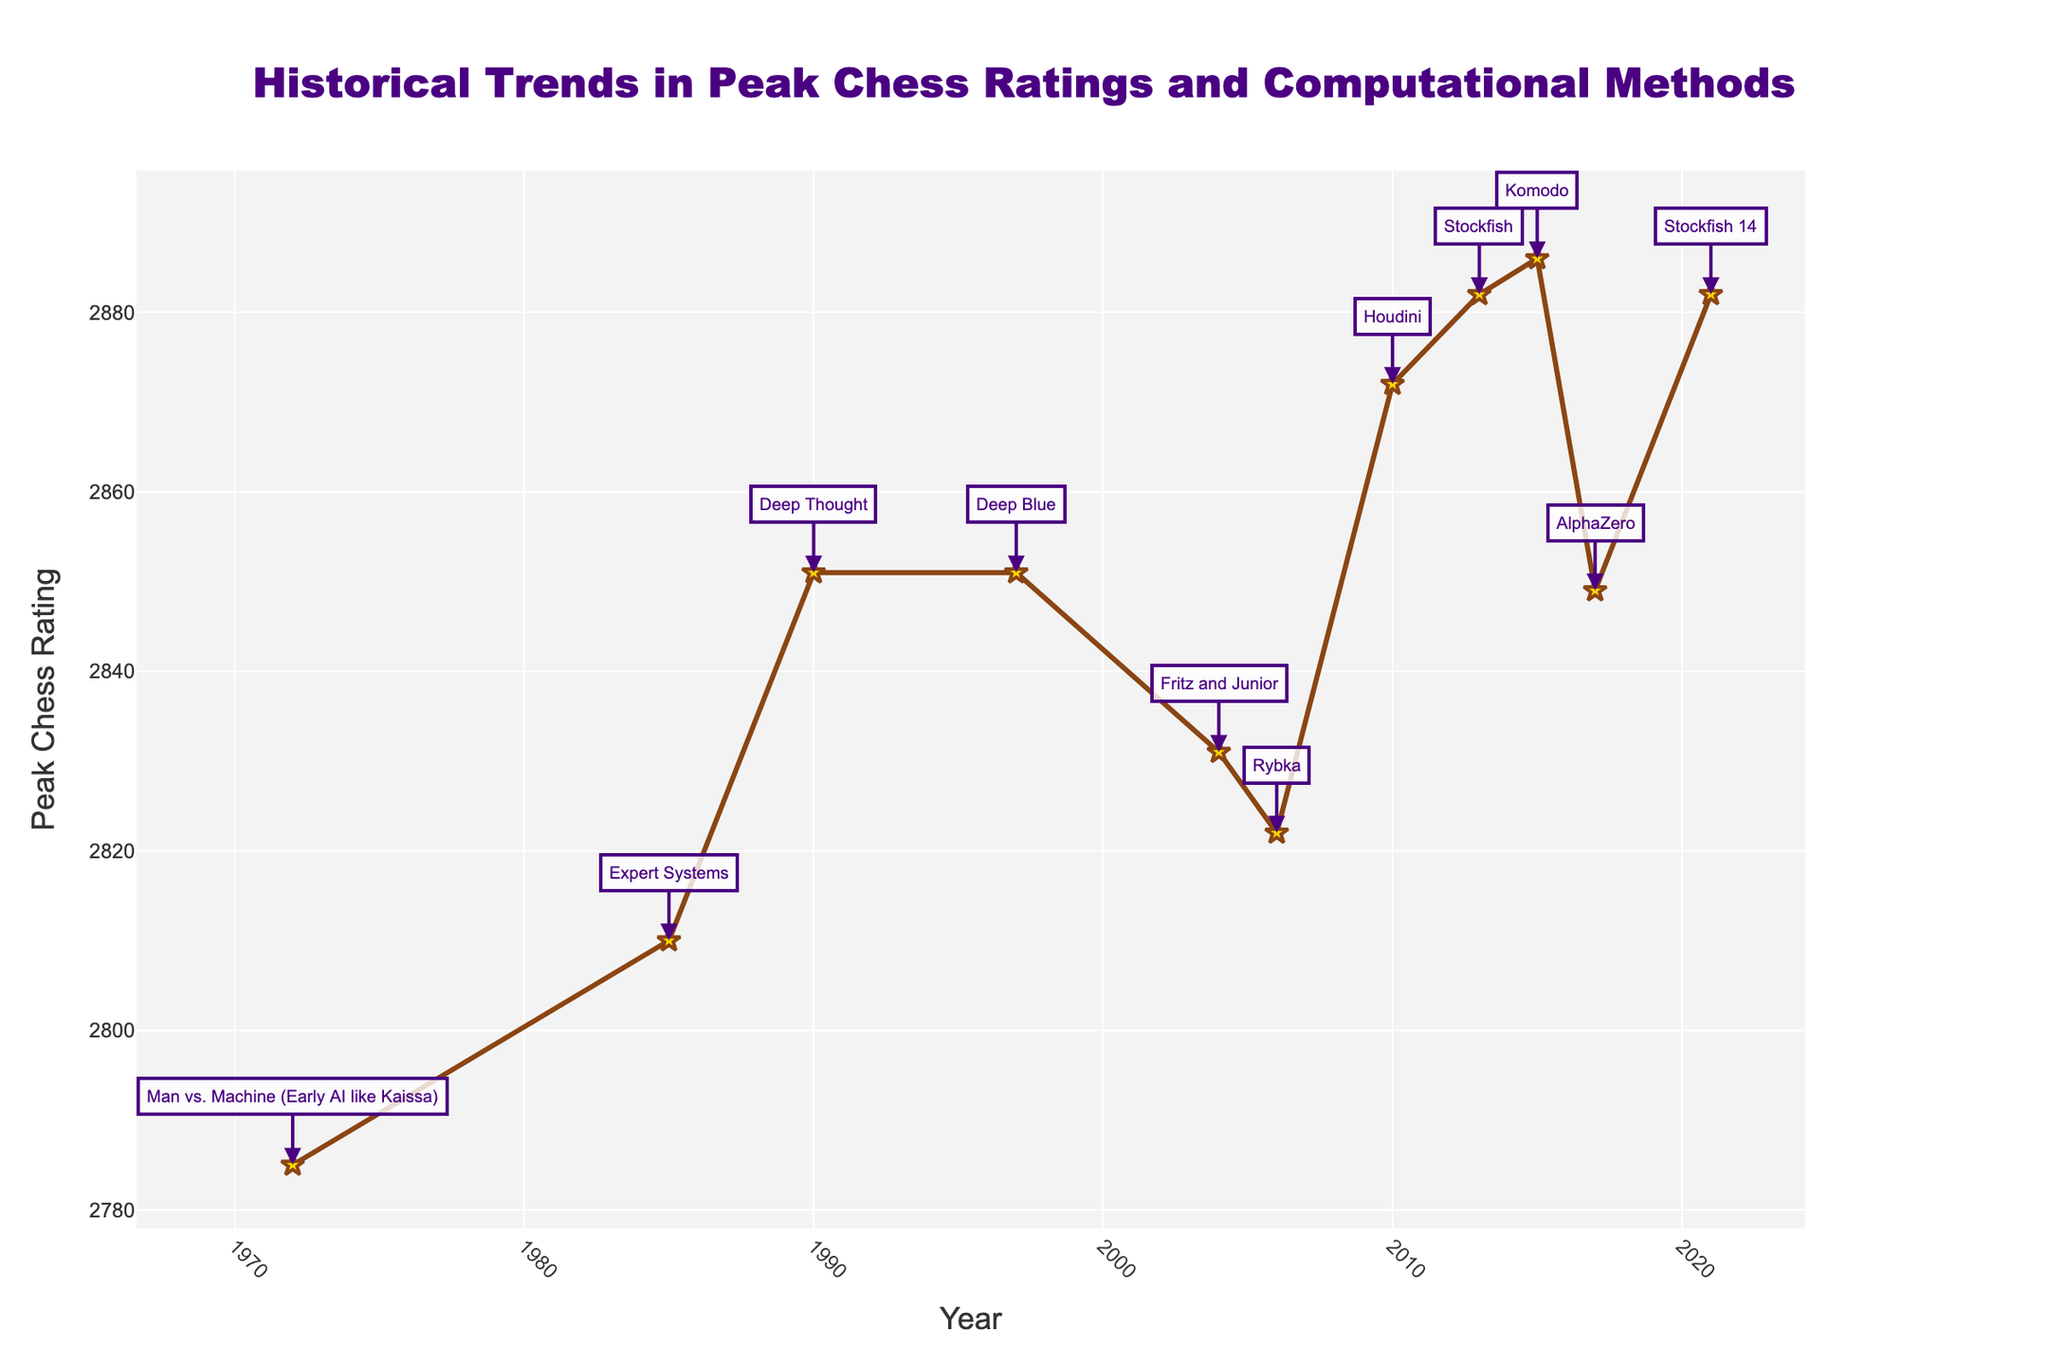What's the title of the figure? The figure's title is situated at the top center and it provides an overview of what is being represented.
Answer: "Historical Trends in Peak Chess Ratings and Computational Methods" What is the peak chess rating in the year 2004? Look at the data point corresponding to the year 2004 along the x-axis and then check the y-value.
Answer: 2831 Compare the peak chess ratings in 1997 and 2017. Which year had a higher rating? Find the corresponding data points for 1997 and 2017 along the x-axis and compare their y-values.
Answer: 1997 What computational method was popular in 1985? Identify the annotation linked to the data point for the year 1985. The text in the annotation indicates the popular computational method.
Answer: Expert Systems What is the range of peak chess ratings shown in the figure? Identify the minimum and maximum peak chess ratings on the y-axis.
Answer: 2785 to 2886 How many years are displayed in this figure? Count the number of unique data points along the x-axis, each corresponding to a different year.
Answer: 11 During which year did Stockfish become the popular computational method? Check the annotations to find the year(s) associated with Stockfish.
Answer: 2013 and 2021 What is the overall trend in peak chess ratings from 1972 to 2021? Observe the overall progression of the line connecting the data points from left (1972) to right (2021).
Answer: Generally increasing Which year marks the first occurrence of a peak chess rating above 2850? Locate the data point where the chess rating first exceeds 2850 and note the corresponding year.
Answer: 1990 Is there a year when the peak chess rating remained unchanged from a previous year? If yes, specify the years. Check for repeated data points along the y-axis to identify any years where the rating did not change.
Answer: 1990 and 1997 both have the rating of 2851 